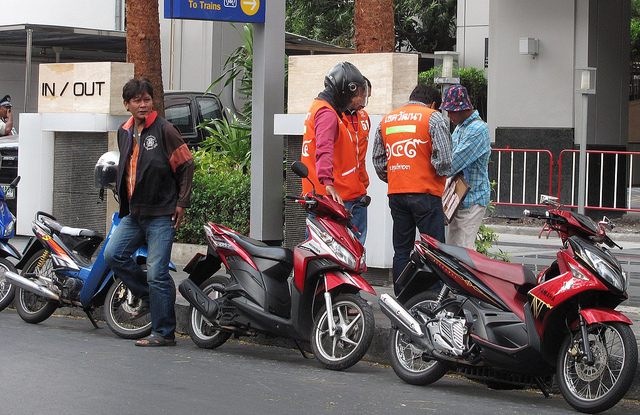Identify and read out the text in this image. IN OUT 51 TO 